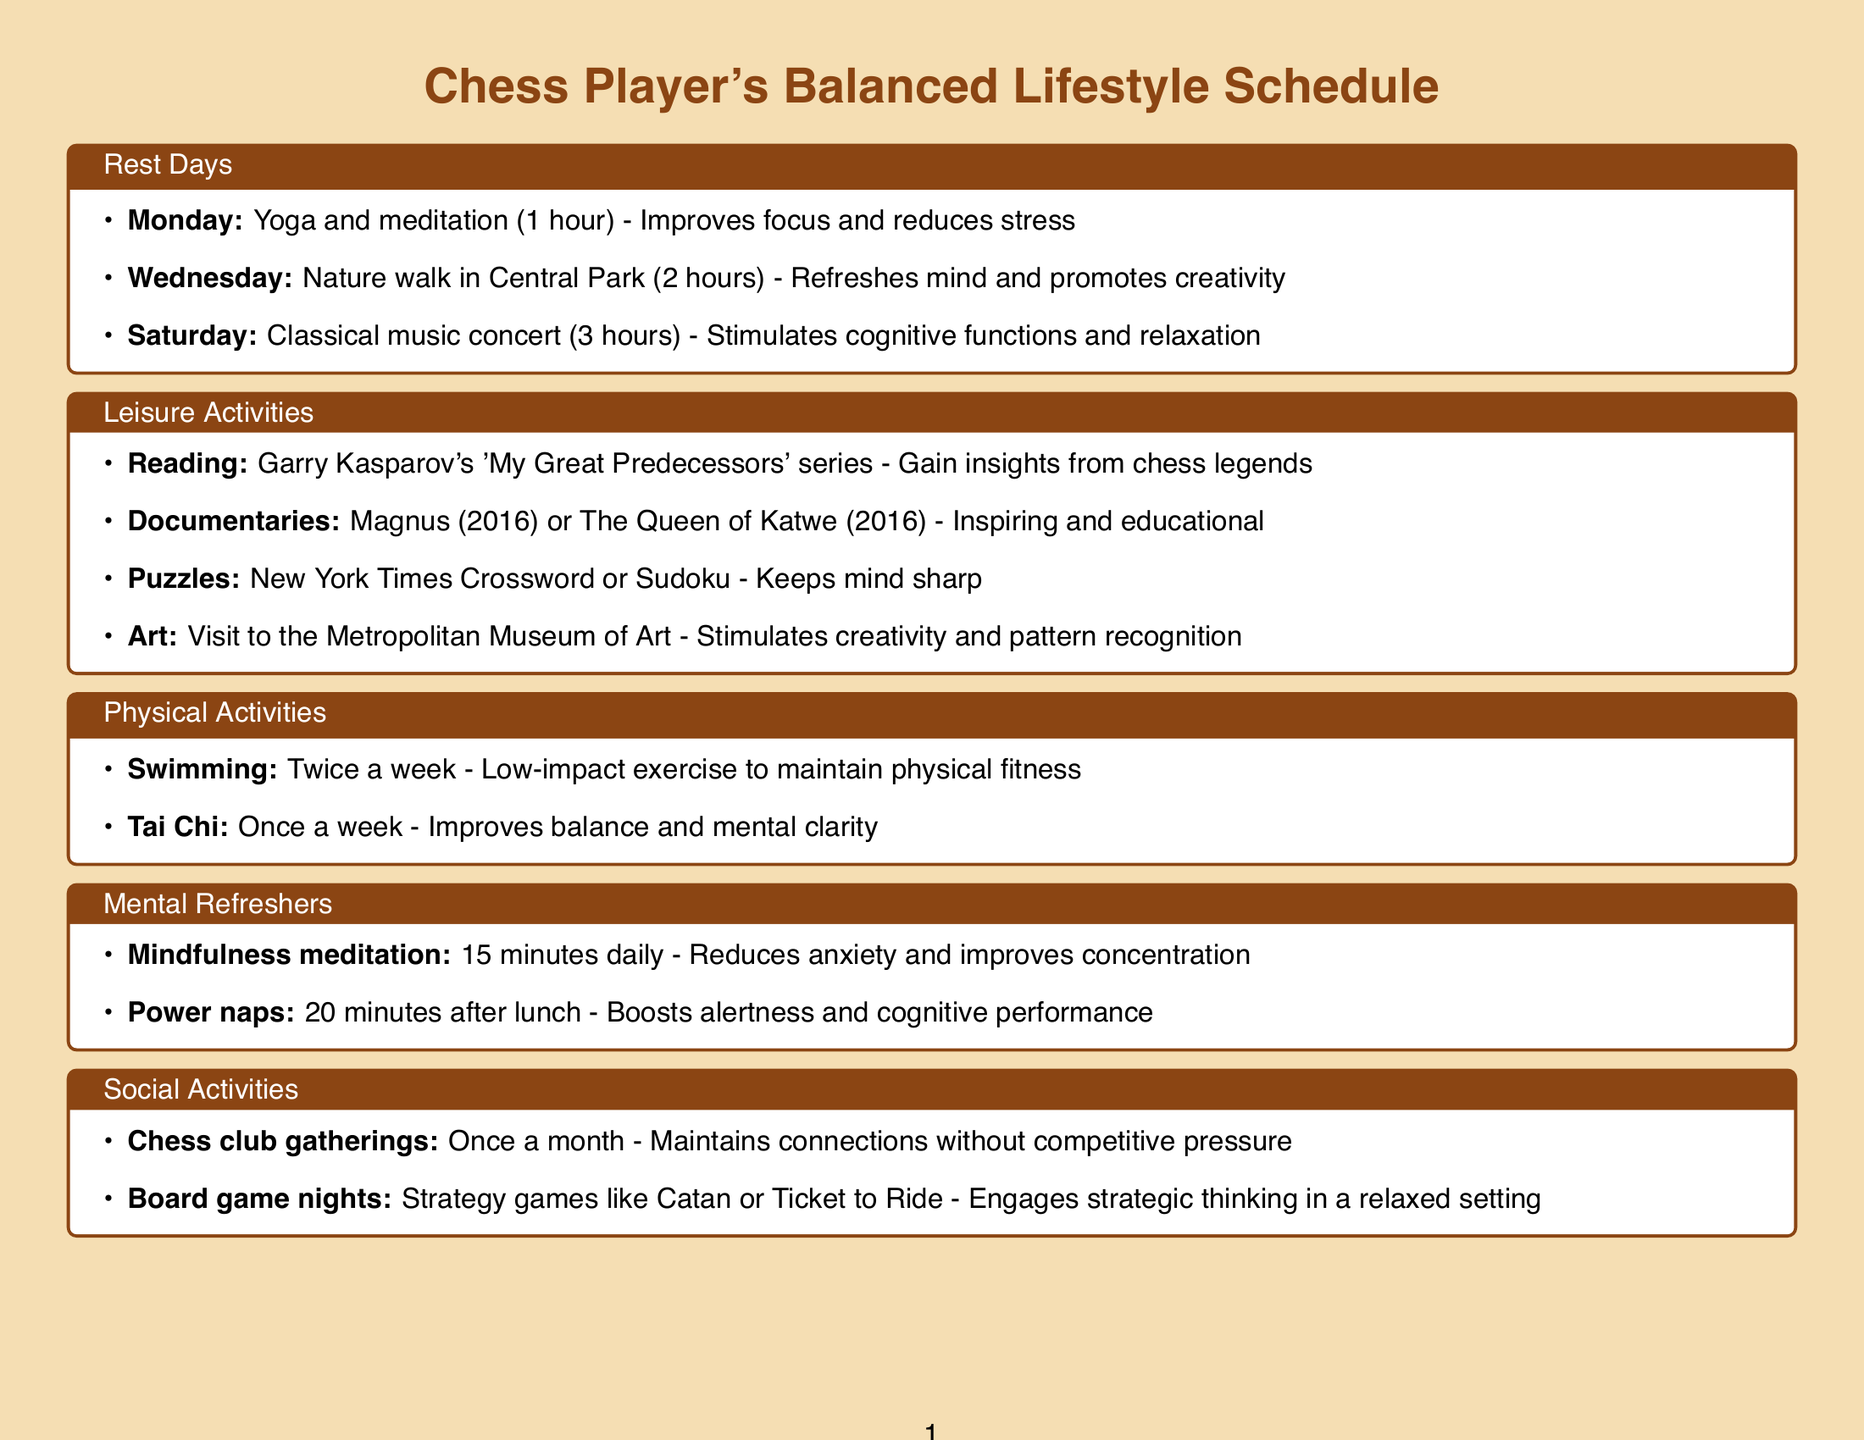What activity is scheduled for Monday? The document lists Yoga and meditation for Monday as the rest day activity.
Answer: Yoga and meditation How long is the nature walk scheduled for? The nature walk in Central Park is scheduled for 2 hours as indicated in the document.
Answer: 2 hours What is the benefit of attending a classical music concert? The document states that attending a classical music concert stimulates cognitive functions and relaxation.
Answer: Stimulates cognitive functions and relaxation How often should swimming be done according to the schedule? The physical activities section specifies that swimming should be done twice a week.
Answer: Twice a week What is a recommended leisure activity to engage strategic thinking? The document recommends board game nights as an activity to engage strategic thinking in a relaxed setting.
Answer: Board game nights What type of food is suggested to boost brain function? Brain-boosting foods like blueberries are suggested in the nutrition tips section of the document.
Answer: Blueberries How many minutes is suggested for mindfulness meditation? The document states that mindfulness meditation should be done for 15 minutes daily.
Answer: 15 minutes On which day are chess club gatherings held? The social activities schedule mentions that chess club social gatherings occur once a month without specifying a day.
Answer: Once a month What is the duration of power naps recommended after lunch? The document specifies that power naps should last for 20 minutes after lunch.
Answer: 20 minutes 